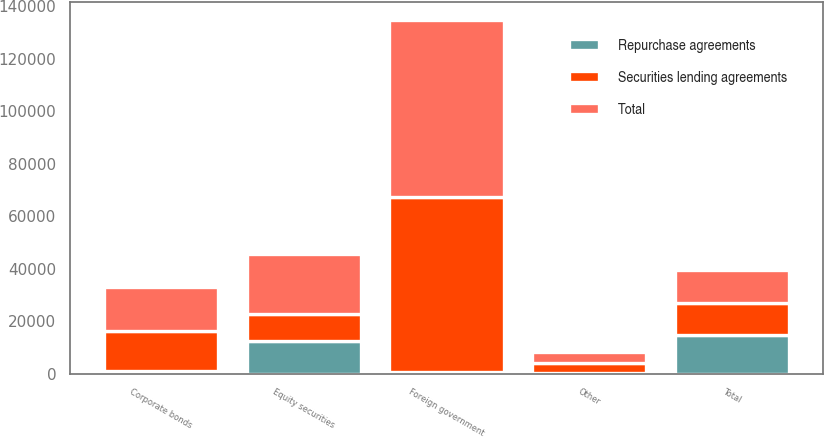<chart> <loc_0><loc_0><loc_500><loc_500><stacked_bar_chart><ecel><fcel>Foreign government<fcel>Corporate bonds<fcel>Equity securities<fcel>Other<fcel>Total<nl><fcel>Securities lending agreements<fcel>66633<fcel>15355<fcel>10297<fcel>3862<fcel>12484<nl><fcel>Repurchase agreements<fcel>789<fcel>1085<fcel>12484<fcel>299<fcel>14657<nl><fcel>Total<fcel>67422<fcel>16440<fcel>22781<fcel>4161<fcel>12484<nl></chart> 